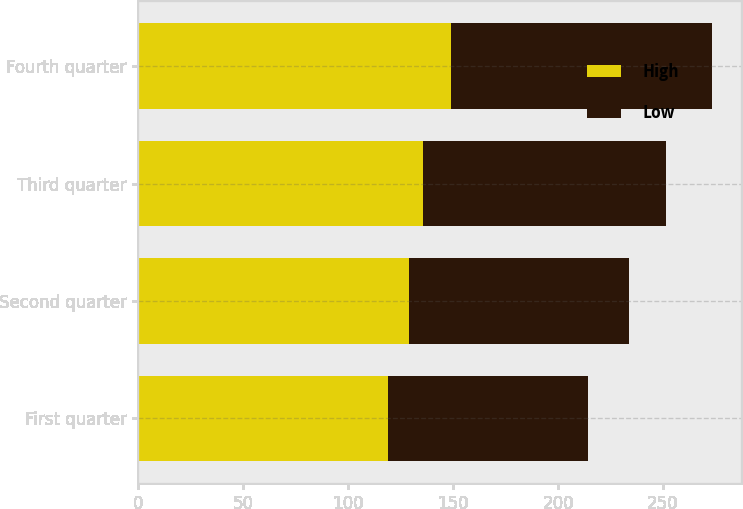Convert chart to OTSL. <chart><loc_0><loc_0><loc_500><loc_500><stacked_bar_chart><ecel><fcel>First quarter<fcel>Second quarter<fcel>Third quarter<fcel>Fourth quarter<nl><fcel>High<fcel>118.78<fcel>128.95<fcel>135.51<fcel>149.07<nl><fcel>Low<fcel>95.59<fcel>104.74<fcel>115.97<fcel>124.17<nl></chart> 